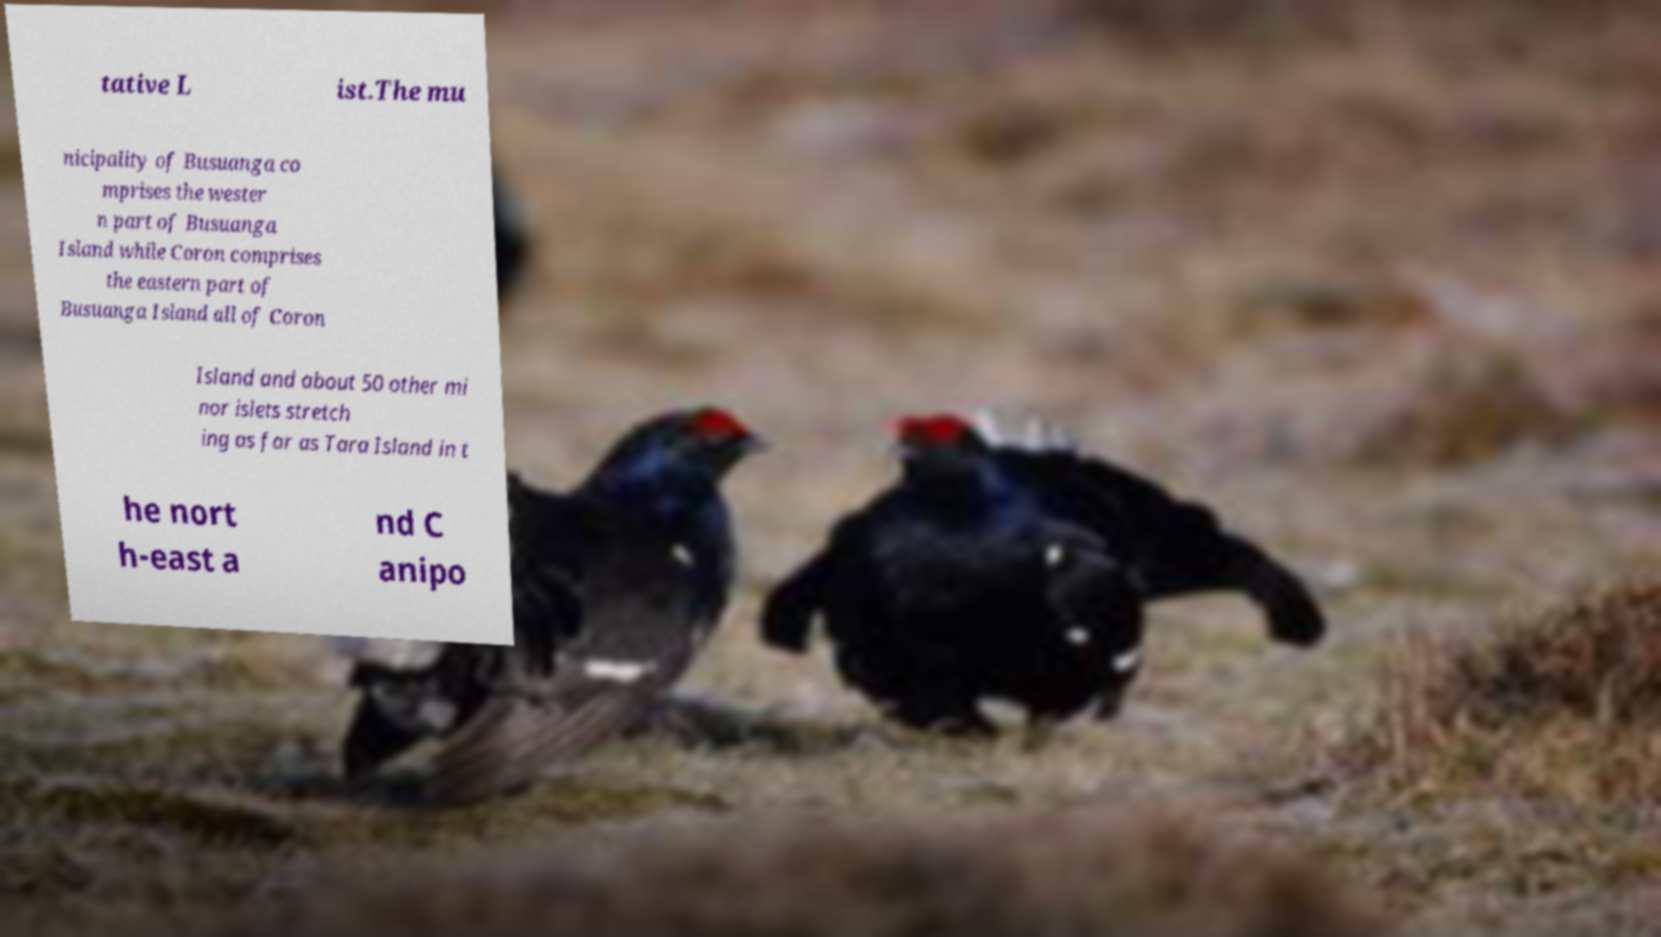Can you read and provide the text displayed in the image?This photo seems to have some interesting text. Can you extract and type it out for me? tative L ist.The mu nicipality of Busuanga co mprises the wester n part of Busuanga Island while Coron comprises the eastern part of Busuanga Island all of Coron Island and about 50 other mi nor islets stretch ing as far as Tara Island in t he nort h-east a nd C anipo 